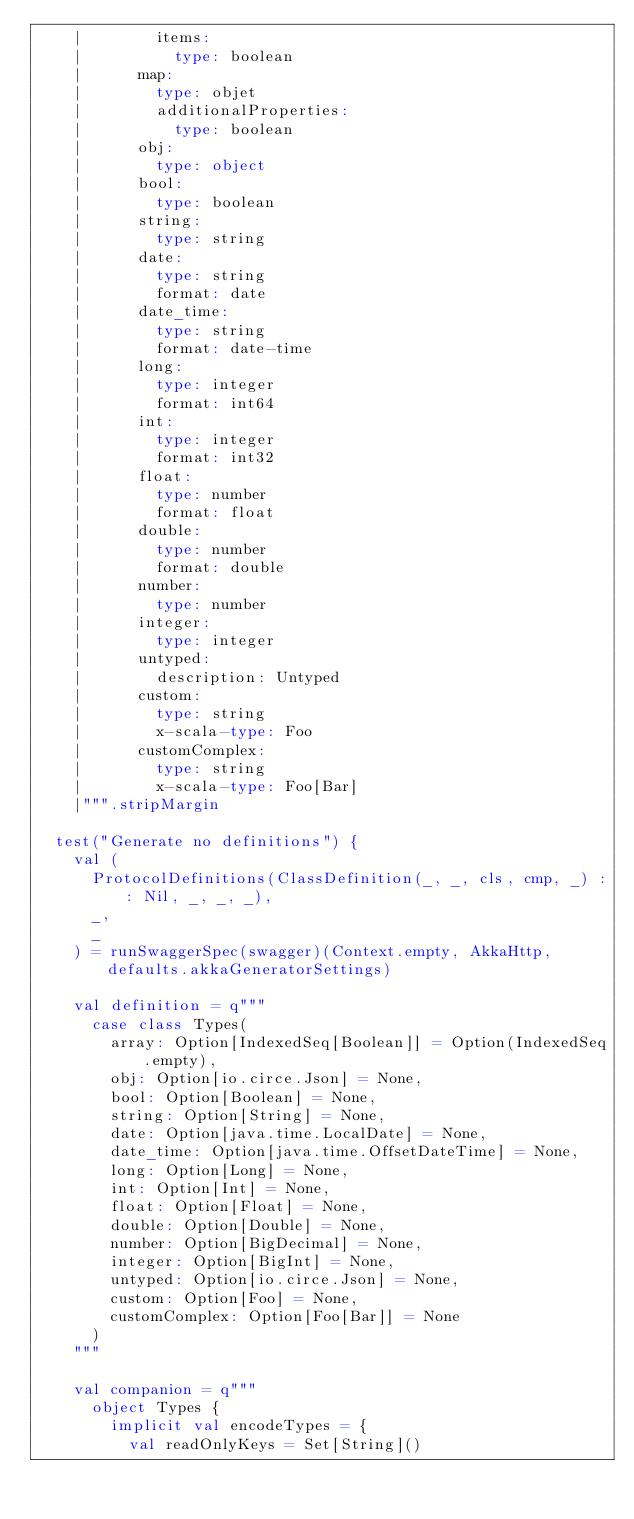<code> <loc_0><loc_0><loc_500><loc_500><_Scala_>    |        items:
    |          type: boolean
    |      map:
    |        type: objet
    |        additionalProperties:
    |          type: boolean
    |      obj:
    |        type: object
    |      bool:
    |        type: boolean
    |      string:
    |        type: string
    |      date:
    |        type: string
    |        format: date
    |      date_time:
    |        type: string
    |        format: date-time
    |      long:
    |        type: integer
    |        format: int64
    |      int:
    |        type: integer
    |        format: int32
    |      float:
    |        type: number
    |        format: float
    |      double:
    |        type: number
    |        format: double
    |      number:
    |        type: number
    |      integer:
    |        type: integer
    |      untyped:
    |        description: Untyped
    |      custom:
    |        type: string
    |        x-scala-type: Foo
    |      customComplex:
    |        type: string
    |        x-scala-type: Foo[Bar]
    |""".stripMargin

  test("Generate no definitions") {
    val (
      ProtocolDefinitions(ClassDefinition(_, _, cls, cmp, _) :: Nil, _, _, _),
      _,
      _
    ) = runSwaggerSpec(swagger)(Context.empty, AkkaHttp, defaults.akkaGeneratorSettings)

    val definition = q"""
      case class Types(
        array: Option[IndexedSeq[Boolean]] = Option(IndexedSeq.empty),
        obj: Option[io.circe.Json] = None,
        bool: Option[Boolean] = None,
        string: Option[String] = None,
        date: Option[java.time.LocalDate] = None,
        date_time: Option[java.time.OffsetDateTime] = None,
        long: Option[Long] = None,
        int: Option[Int] = None,
        float: Option[Float] = None,
        double: Option[Double] = None,
        number: Option[BigDecimal] = None,
        integer: Option[BigInt] = None,
        untyped: Option[io.circe.Json] = None,
        custom: Option[Foo] = None,
        customComplex: Option[Foo[Bar]] = None
      )
    """

    val companion = q"""
      object Types {
        implicit val encodeTypes = {
          val readOnlyKeys = Set[String]()</code> 